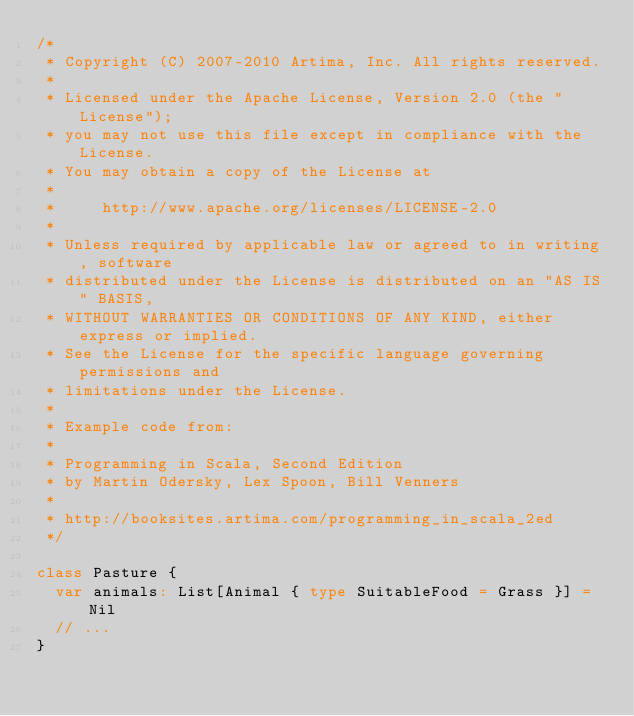Convert code to text. <code><loc_0><loc_0><loc_500><loc_500><_Scala_>/*
 * Copyright (C) 2007-2010 Artima, Inc. All rights reserved.
 * 
 * Licensed under the Apache License, Version 2.0 (the "License");
 * you may not use this file except in compliance with the License.
 * You may obtain a copy of the License at
 * 
 *     http://www.apache.org/licenses/LICENSE-2.0
 * 
 * Unless required by applicable law or agreed to in writing, software
 * distributed under the License is distributed on an "AS IS" BASIS,
 * WITHOUT WARRANTIES OR CONDITIONS OF ANY KIND, either express or implied.
 * See the License for the specific language governing permissions and
 * limitations under the License.
 *
 * Example code from:
 *
 * Programming in Scala, Second Edition
 * by Martin Odersky, Lex Spoon, Bill Venners
 *
 * http://booksites.artima.com/programming_in_scala_2ed
 */

class Pasture {
  var animals: List[Animal { type SuitableFood = Grass }] = Nil
  // ...
}
</code> 